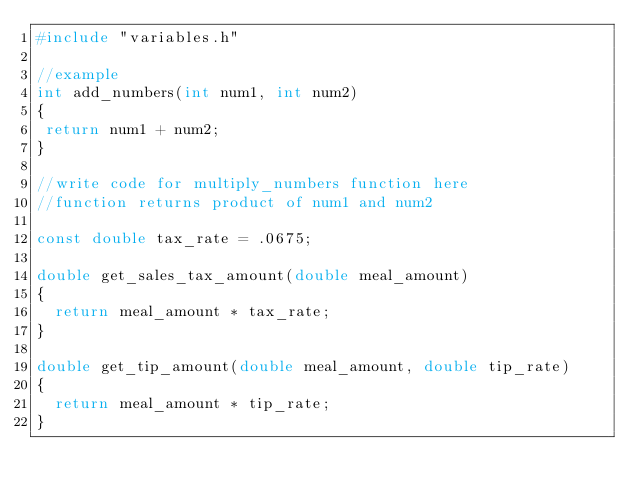Convert code to text. <code><loc_0><loc_0><loc_500><loc_500><_C++_>#include "variables.h"

//example
int add_numbers(int num1, int num2)
{
 return num1 + num2;
}

//write code for multiply_numbers function here
//function returns product of num1 and num2

const double tax_rate = .0675;

double get_sales_tax_amount(double meal_amount)
{
  return meal_amount * tax_rate;
}

double get_tip_amount(double meal_amount, double tip_rate)
{
  return meal_amount * tip_rate;
}</code> 